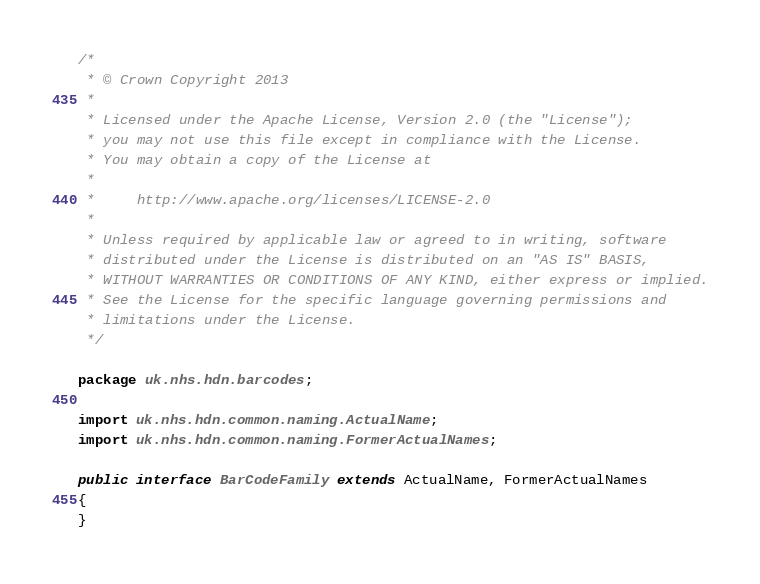Convert code to text. <code><loc_0><loc_0><loc_500><loc_500><_Java_>/*
 * © Crown Copyright 2013
 *
 * Licensed under the Apache License, Version 2.0 (the "License");
 * you may not use this file except in compliance with the License.
 * You may obtain a copy of the License at
 *
 *     http://www.apache.org/licenses/LICENSE-2.0
 *
 * Unless required by applicable law or agreed to in writing, software
 * distributed under the License is distributed on an "AS IS" BASIS,
 * WITHOUT WARRANTIES OR CONDITIONS OF ANY KIND, either express or implied.
 * See the License for the specific language governing permissions and
 * limitations under the License.
 */

package uk.nhs.hdn.barcodes;

import uk.nhs.hdn.common.naming.ActualName;
import uk.nhs.hdn.common.naming.FormerActualNames;

public interface BarCodeFamily extends ActualName, FormerActualNames
{
}
</code> 